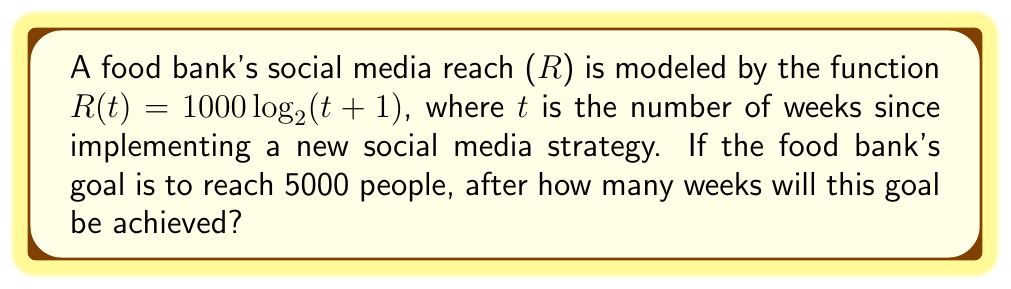Provide a solution to this math problem. To solve this problem, we need to follow these steps:

1) We're looking for t when R(t) = 5000. So, we set up the equation:
   
   $5000 = 1000 \log_2(t + 1)$

2) Divide both sides by 1000:
   
   $5 = \log_2(t + 1)$

3) To solve for t, we need to apply the inverse function of $\log_2$, which is $2^x$:
   
   $2^5 = t + 1$

4) Calculate $2^5$:
   
   $32 = t + 1$

5) Subtract 1 from both sides:
   
   $31 = t$

Therefore, it will take 31 weeks to reach the goal of 5000 people.
Answer: 31 weeks 